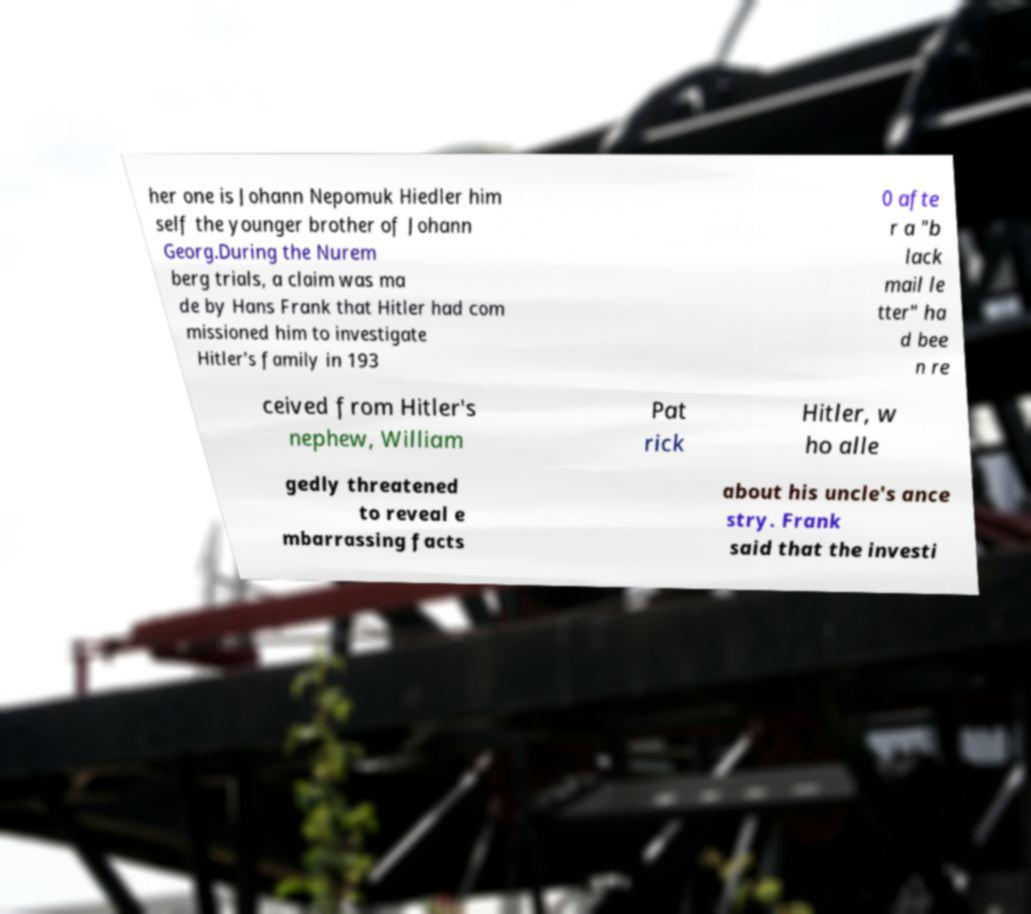Please read and relay the text visible in this image. What does it say? her one is Johann Nepomuk Hiedler him self the younger brother of Johann Georg.During the Nurem berg trials, a claim was ma de by Hans Frank that Hitler had com missioned him to investigate Hitler's family in 193 0 afte r a "b lack mail le tter" ha d bee n re ceived from Hitler's nephew, William Pat rick Hitler, w ho alle gedly threatened to reveal e mbarrassing facts about his uncle's ance stry. Frank said that the investi 